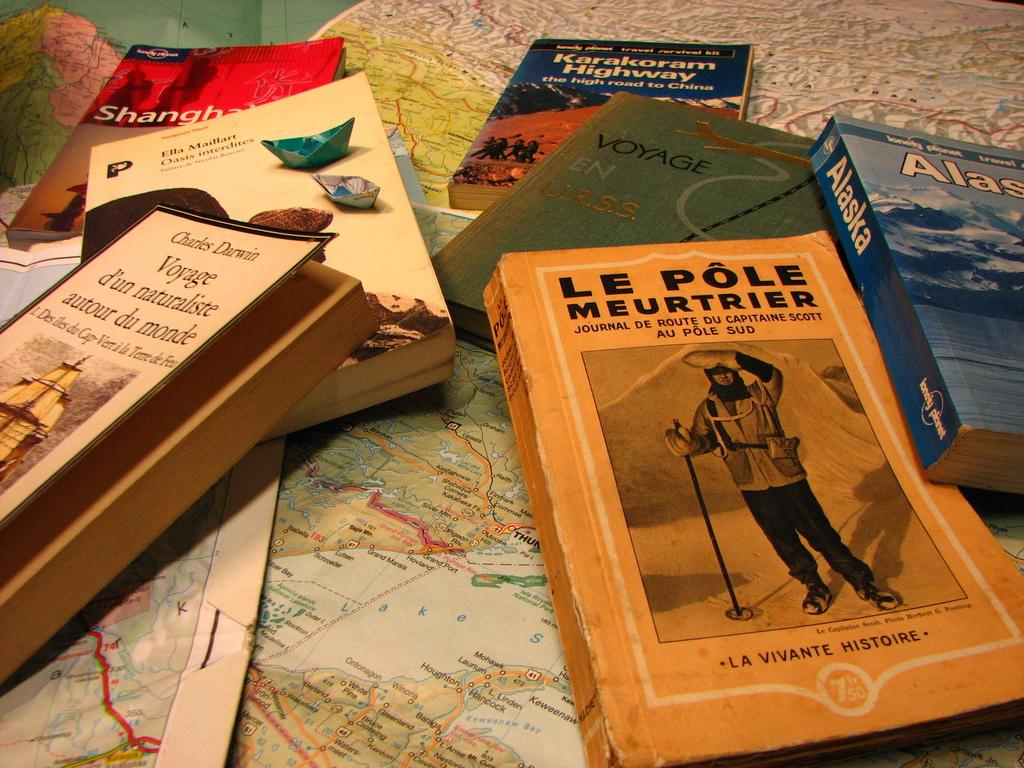Provide a one-sentence caption for the provided image. A small pile of travel books which include one on Alaska over a map. 